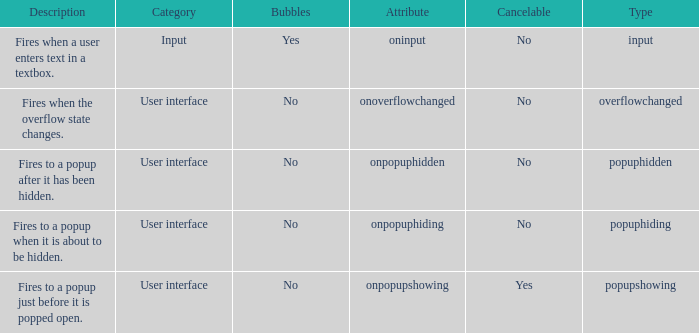 how many bubbles with category being input 1.0. 